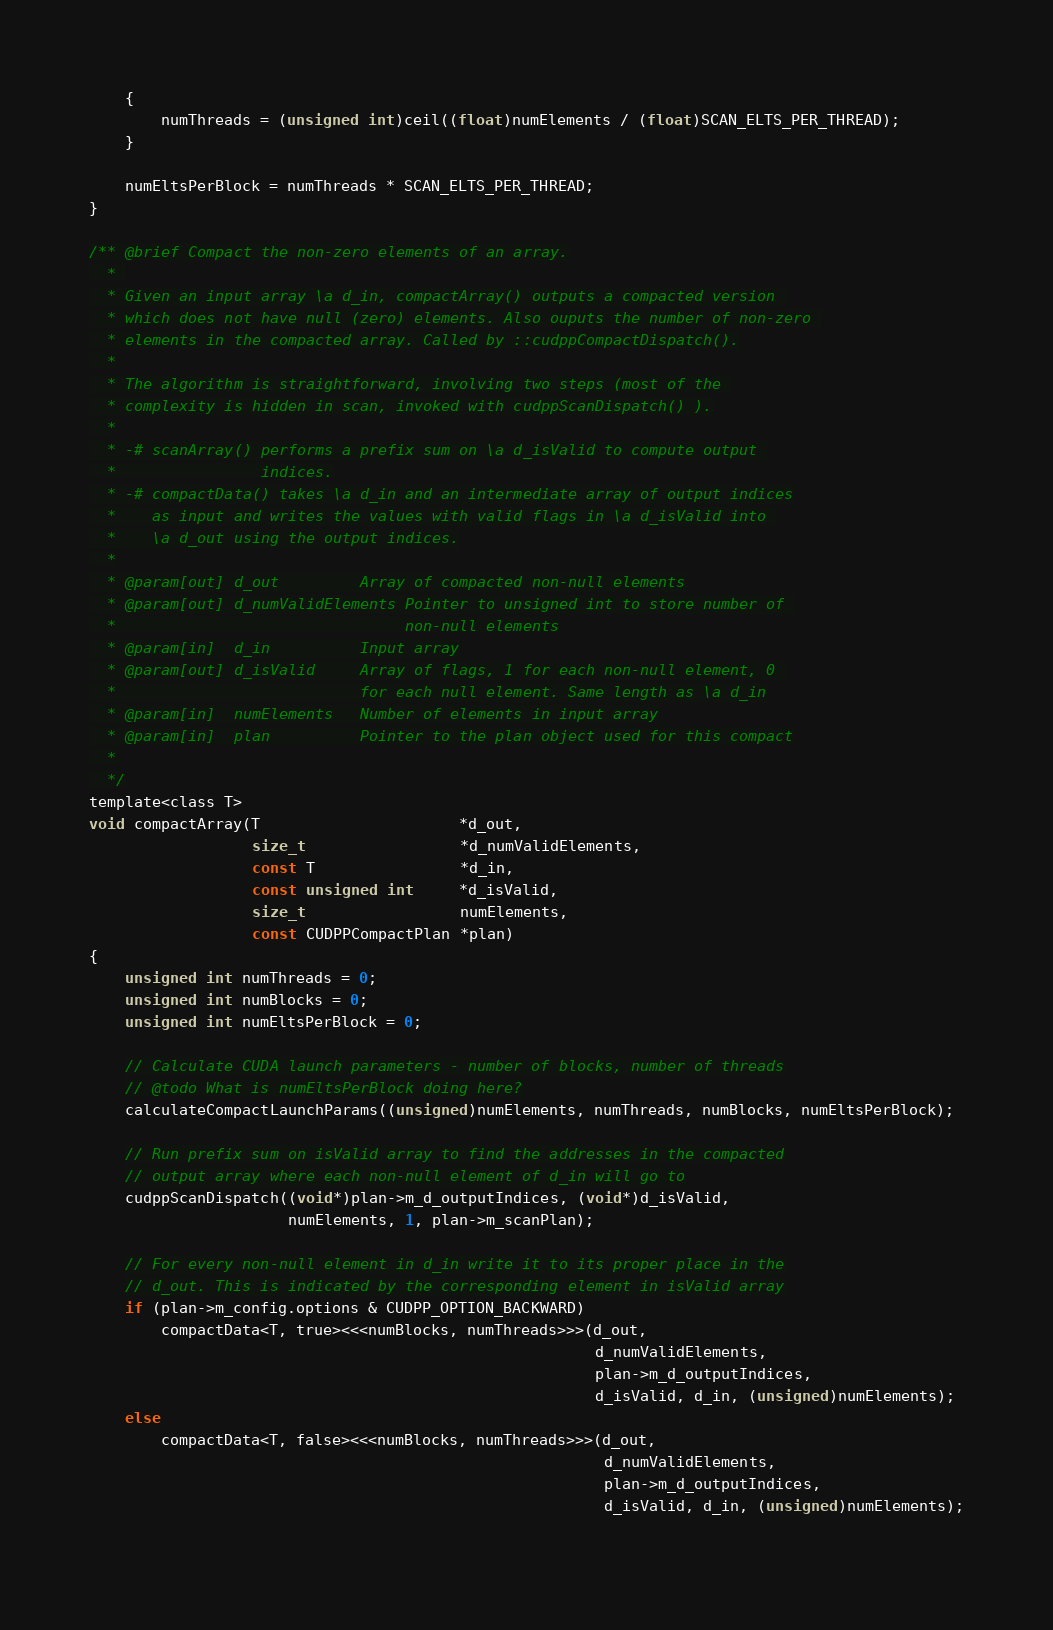Convert code to text. <code><loc_0><loc_0><loc_500><loc_500><_Cuda_>    {
        numThreads = (unsigned int)ceil((float)numElements / (float)SCAN_ELTS_PER_THREAD);
    }

    numEltsPerBlock = numThreads * SCAN_ELTS_PER_THREAD;
}

/** @brief Compact the non-zero elements of an array.
  * 
  * Given an input array \a d_in, compactArray() outputs a compacted version 
  * which does not have null (zero) elements. Also ouputs the number of non-zero 
  * elements in the compacted array. Called by ::cudppCompactDispatch().
  *
  * The algorithm is straightforward, involving two steps (most of the 
  * complexity is hidden in scan, invoked with cudppScanDispatch() ).
  *
  * -# scanArray() performs a prefix sum on \a d_isValid to compute output 
  *                indices.
  * -# compactData() takes \a d_in and an intermediate array of output indices
  *    as input and writes the values with valid flags in \a d_isValid into 
  *    \a d_out using the output indices.
  *
  * @param[out] d_out         Array of compacted non-null elements
  * @param[out] d_numValidElements Pointer to unsigned int to store number of 
  *                                non-null elements
  * @param[in]  d_in          Input array
  * @param[out] d_isValid     Array of flags, 1 for each non-null element, 0 
  *                           for each null element. Same length as \a d_in
  * @param[in]  numElements   Number of elements in input array
  * @param[in]  plan          Pointer to the plan object used for this compact
  *
  */
template<class T>
void compactArray(T                      *d_out, 
                  size_t                 *d_numValidElements,
                  const T                *d_in, 
                  const unsigned int     *d_isValid,
                  size_t                 numElements,
                  const CUDPPCompactPlan *plan)
{
    unsigned int numThreads = 0;
    unsigned int numBlocks = 0;
    unsigned int numEltsPerBlock = 0;

    // Calculate CUDA launch parameters - number of blocks, number of threads
    // @todo What is numEltsPerBlock doing here?
    calculateCompactLaunchParams((unsigned)numElements, numThreads, numBlocks, numEltsPerBlock);

    // Run prefix sum on isValid array to find the addresses in the compacted
    // output array where each non-null element of d_in will go to
    cudppScanDispatch((void*)plan->m_d_outputIndices, (void*)d_isValid, 
                      numElements, 1, plan->m_scanPlan);

    // For every non-null element in d_in write it to its proper place in the
    // d_out. This is indicated by the corresponding element in isValid array
    if (plan->m_config.options & CUDPP_OPTION_BACKWARD)
        compactData<T, true><<<numBlocks, numThreads>>>(d_out,
                                                        d_numValidElements,
                                                        plan->m_d_outputIndices, 
                                                        d_isValid, d_in, (unsigned)numElements);
    else
        compactData<T, false><<<numBlocks, numThreads>>>(d_out, 
                                                         d_numValidElements,
                                                         plan->m_d_outputIndices, 
                                                         d_isValid, d_in, (unsigned)numElements);
                                                         </code> 